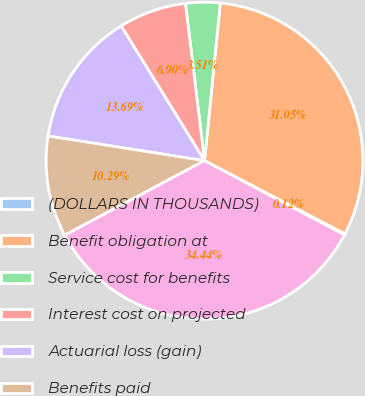Convert chart to OTSL. <chart><loc_0><loc_0><loc_500><loc_500><pie_chart><fcel>(DOLLARS IN THOUSANDS)<fcel>Benefit obligation at<fcel>Service cost for benefits<fcel>Interest cost on projected<fcel>Actuarial loss (gain)<fcel>Benefits paid<fcel>Benefit obligation at end of<nl><fcel>0.12%<fcel>31.05%<fcel>3.51%<fcel>6.9%<fcel>13.69%<fcel>10.29%<fcel>34.44%<nl></chart> 